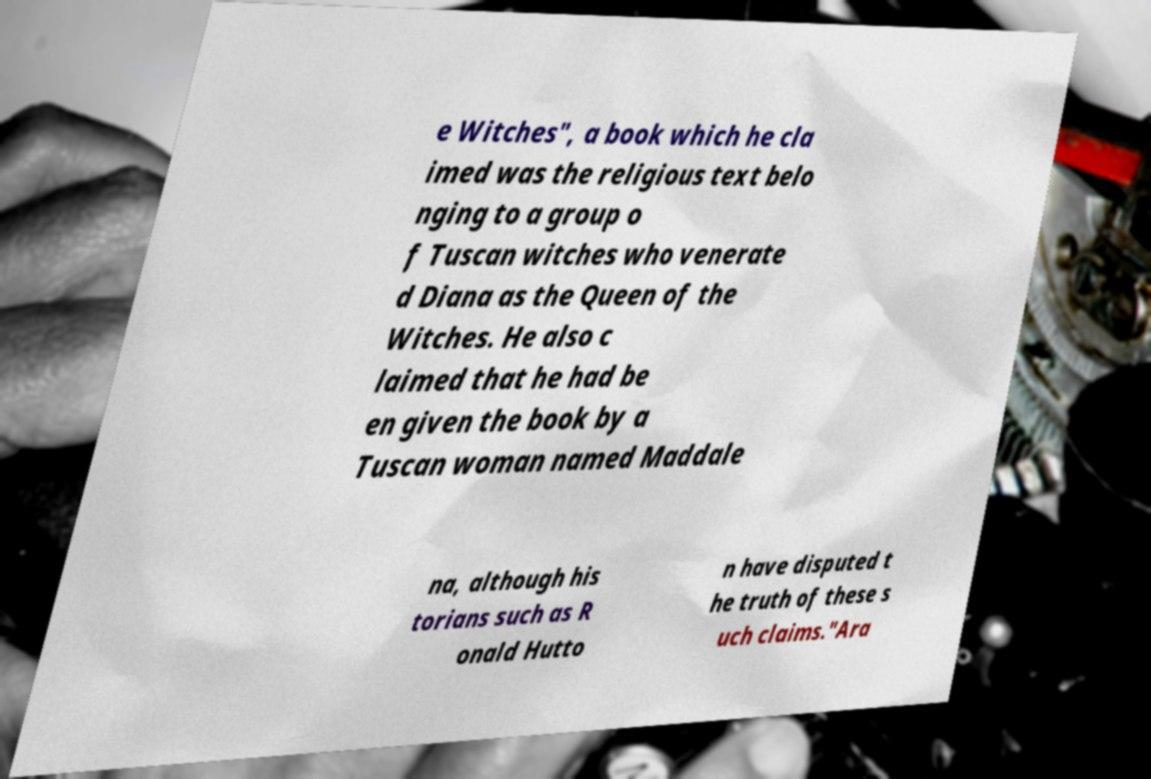Please identify and transcribe the text found in this image. e Witches", a book which he cla imed was the religious text belo nging to a group o f Tuscan witches who venerate d Diana as the Queen of the Witches. He also c laimed that he had be en given the book by a Tuscan woman named Maddale na, although his torians such as R onald Hutto n have disputed t he truth of these s uch claims."Ara 